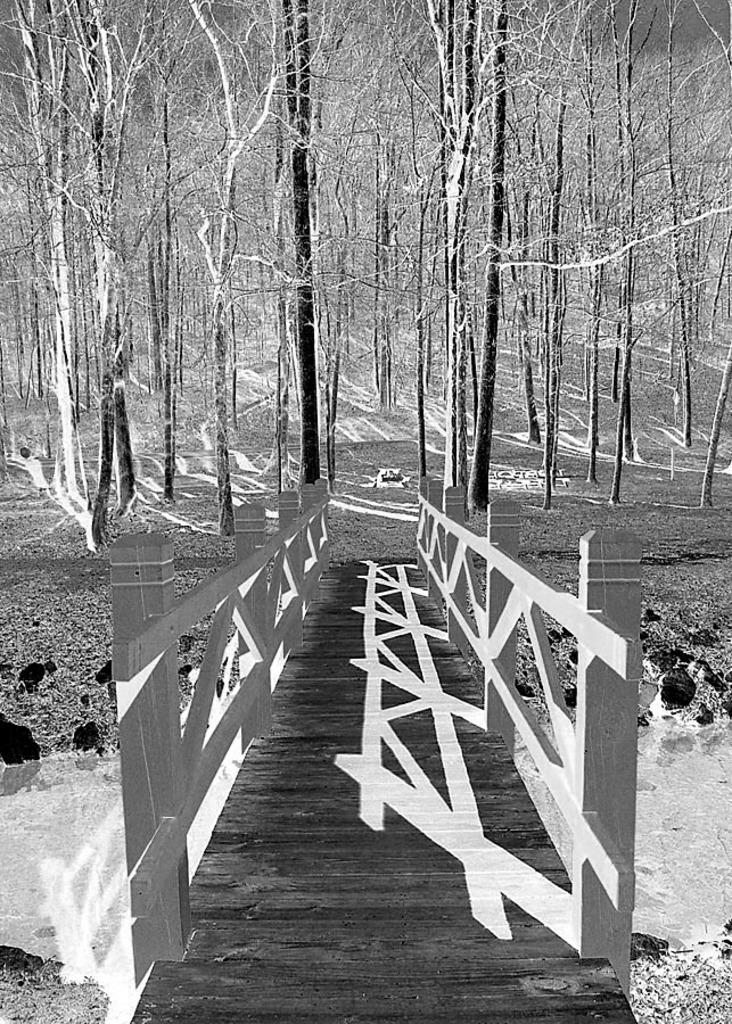What structure is present in the image? There is a bridge in the image. What is the bridge positioned over? The bridge is over a lake. What can be seen in the background of the image? There are trees and the ground visible in the background of the image. How do the friends feel about the dirt on the bridge in the image? There are no friends or dirt mentioned in the image, so it is not possible to answer that question. 